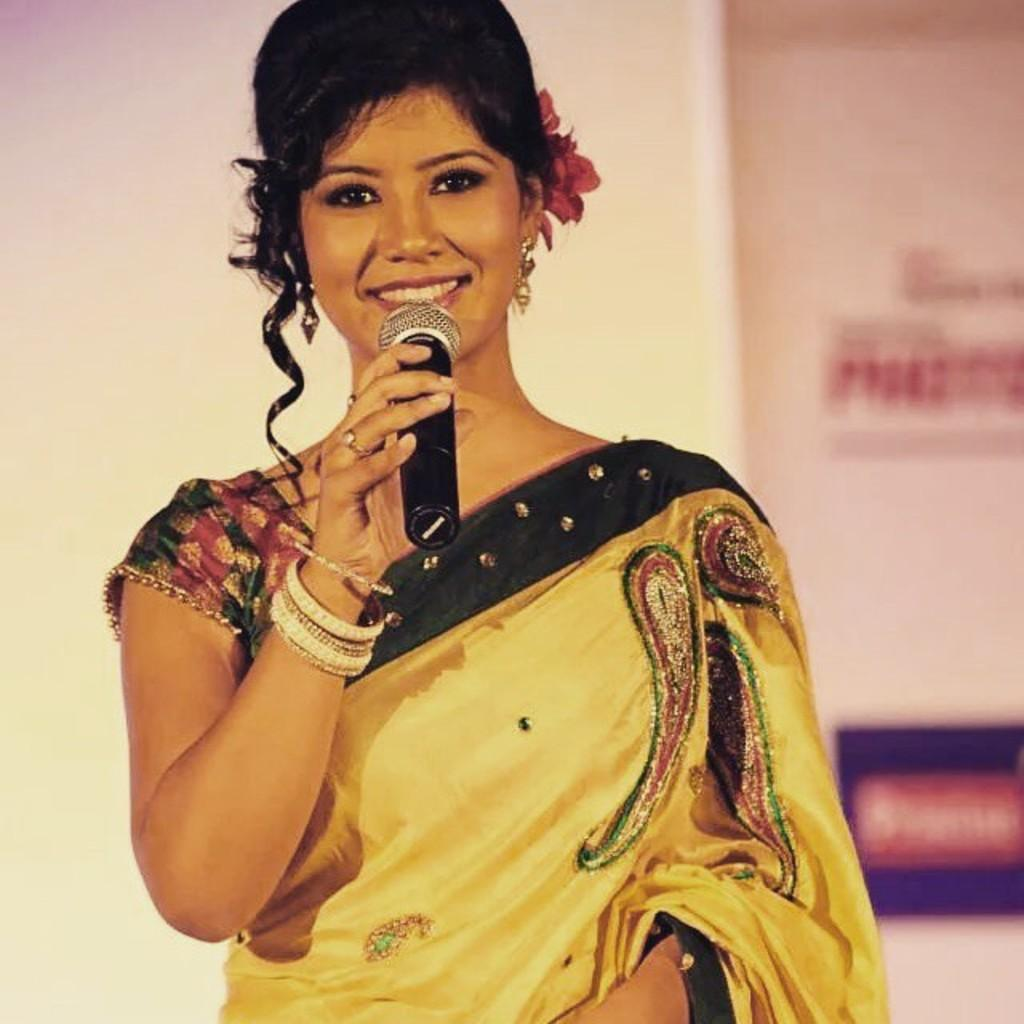What is the main subject of the image? The main subject of the image is a lady. What is the lady holding in the image? The lady is holding a mic. What type of chicken can be seen in the image? There is no chicken present in the image. What type of produce is visible in the image? There is no produce visible in the image. What type of stocking is the lady wearing in the image? The provided facts do not mention any stockings, so it cannot be determined from the image. 